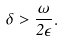<formula> <loc_0><loc_0><loc_500><loc_500>\delta > \frac { \omega } { 2 \epsilon } .</formula> 